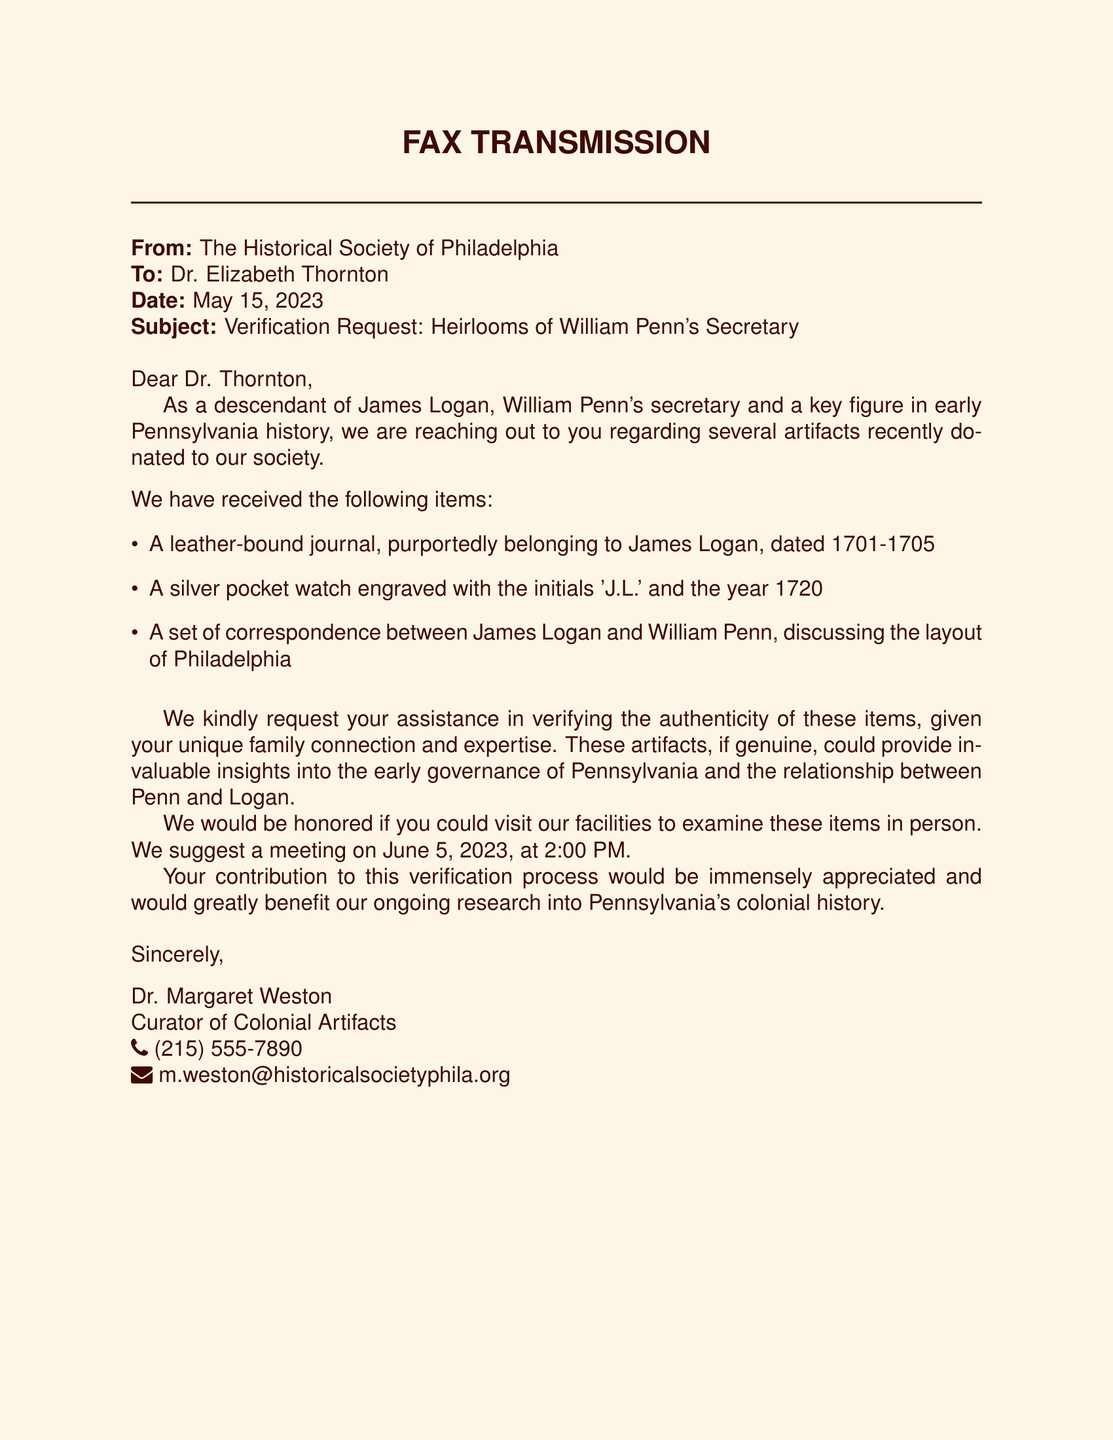What is the date of the fax? The date of the fax is explicitly stated in the document as May 15, 2023.
Answer: May 15, 2023 Who is the sender of the fax? The sender is identified in the document as The Historical Society of Philadelphia.
Answer: The Historical Society of Philadelphia What item is dated between 1701 and 1705? The document lists a leather-bound journal that is purportedly belonging to James Logan and is dated 1701-1705.
Answer: A leather-bound journal What initials are engraved on the pocket watch? The document specifies that the engraved initials on the pocket watch are 'J.L.'.
Answer: J.L What is the proposed meeting date? The proposed meeting date for Dr. Thornton to examine the items is mentioned as June 5, 2023.
Answer: June 5, 2023 What role did James Logan hold? The fax identifies James Logan as William Penn's secretary, providing a clear context about his historical figure.
Answer: Secretary What type of correspondence is included with the artifacts? The document mentions a set of correspondence between James Logan and William Penn.
Answer: Correspondence Who signed the fax? The fax is signed by Dr. Margaret Weston, who is the Curator of Colonial Artifacts.
Answer: Dr. Margaret Weston 